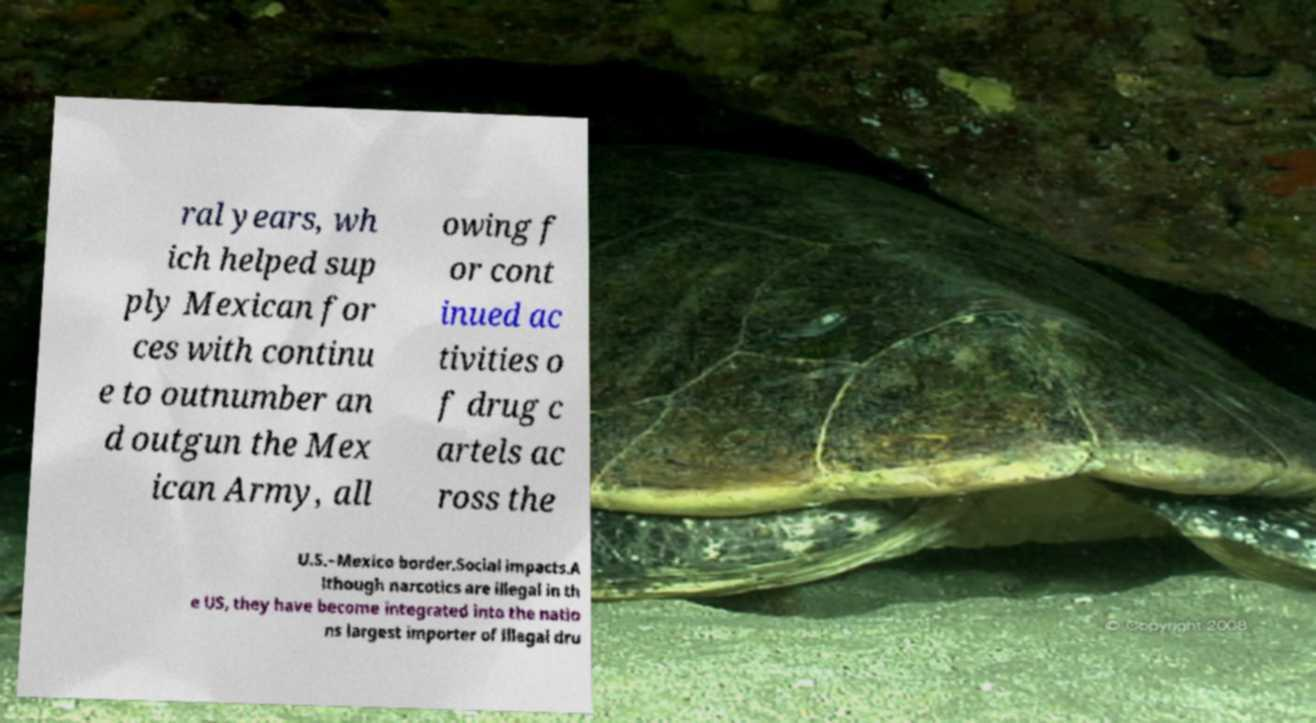Please identify and transcribe the text found in this image. ral years, wh ich helped sup ply Mexican for ces with continu e to outnumber an d outgun the Mex ican Army, all owing f or cont inued ac tivities o f drug c artels ac ross the U.S.–Mexico border.Social impacts.A lthough narcotics are illegal in th e US, they have become integrated into the natio ns largest importer of illegal dru 